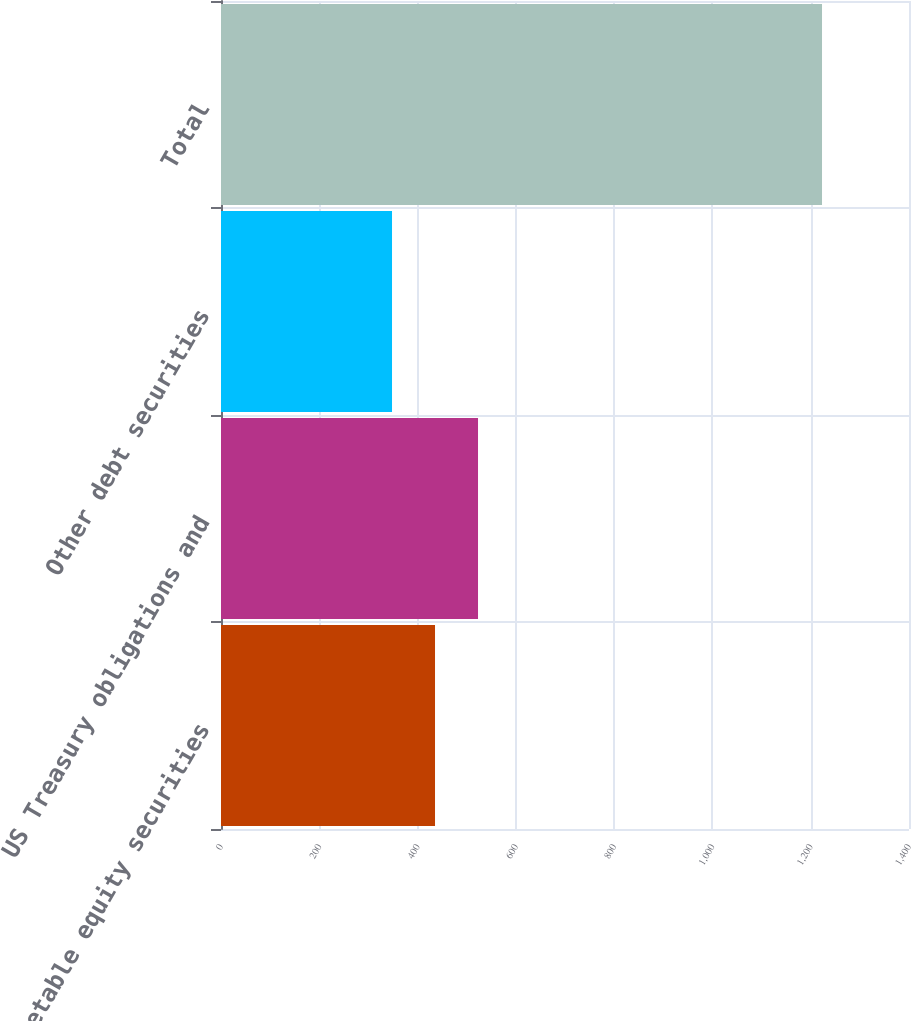Convert chart. <chart><loc_0><loc_0><loc_500><loc_500><bar_chart><fcel>Marketable equity securities<fcel>US Treasury obligations and<fcel>Other debt securities<fcel>Total<nl><fcel>435.5<fcel>523<fcel>348<fcel>1223<nl></chart> 